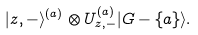<formula> <loc_0><loc_0><loc_500><loc_500>| z , - \rangle ^ { ( a ) } \otimes U _ { z , - } ^ { ( a ) } | G - \{ a \} \rangle .</formula> 